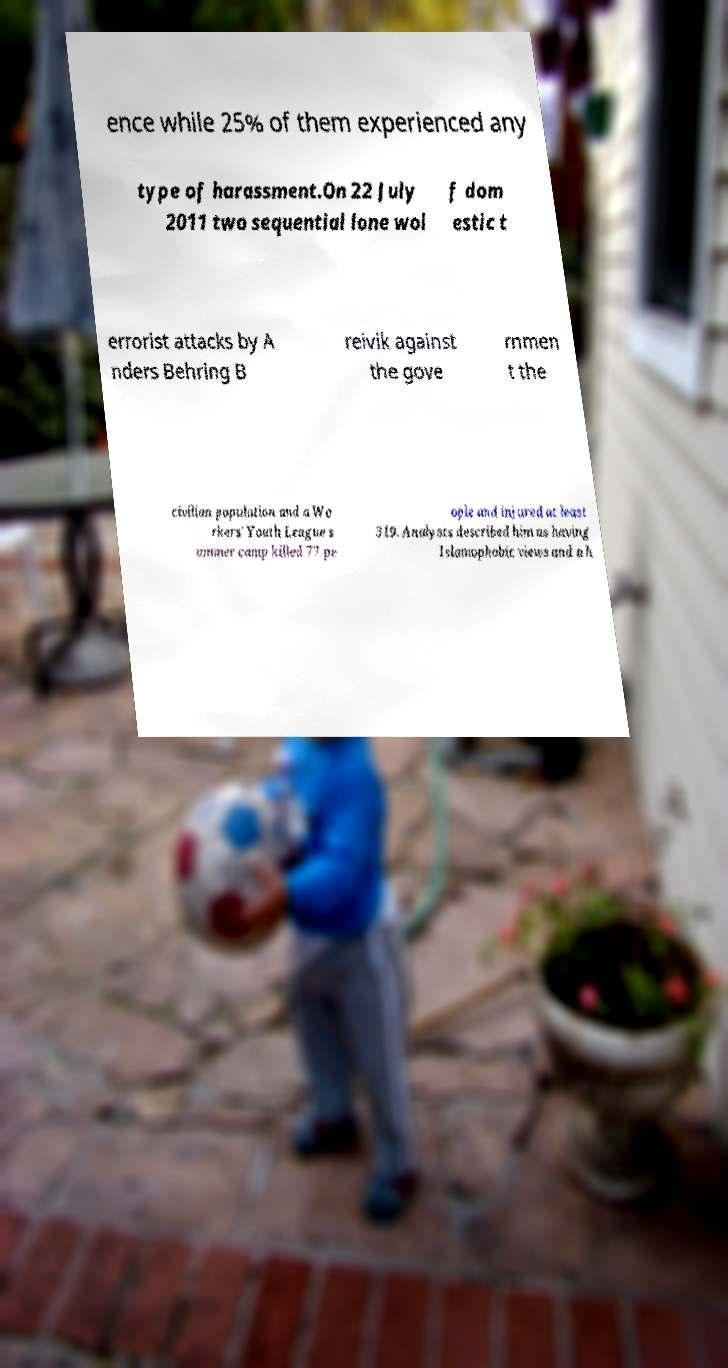I need the written content from this picture converted into text. Can you do that? ence while 25% of them experienced any type of harassment.On 22 July 2011 two sequential lone wol f dom estic t errorist attacks by A nders Behring B reivik against the gove rnmen t the civilian population and a Wo rkers' Youth League s ummer camp killed 77 pe ople and injured at least 319. Analysts described him as having Islamophobic views and a h 